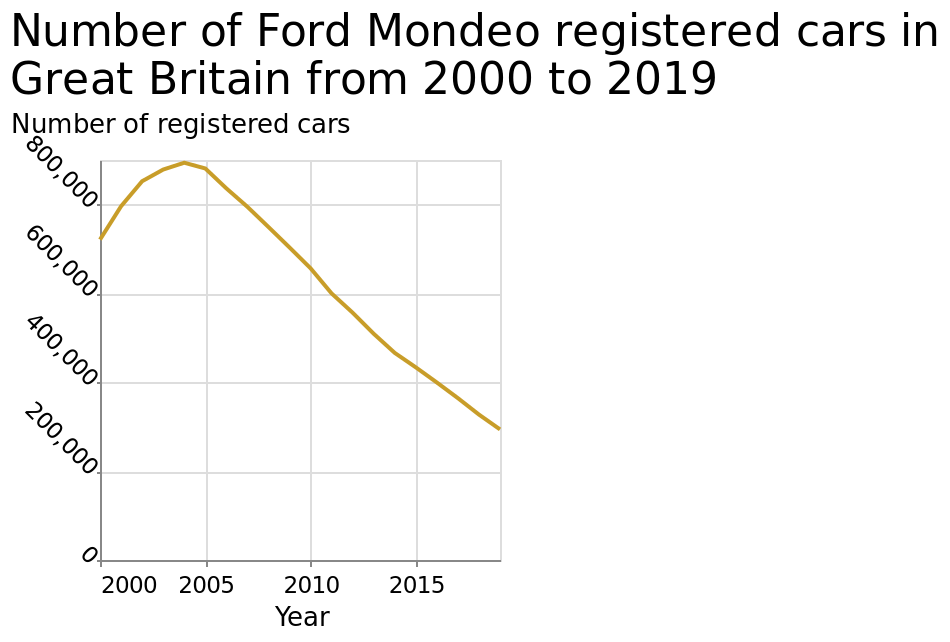<image>
What is the title of the line diagram? The line diagram represents the "Number of Ford Mondeo registered cars in Great Britain from 2000 to 2019". When did the number of registered cars start to decrease?  The number of registered cars started to decrease in 2004. Can you describe the trend in the number of registered cars after 2004? After 2004, the number of registered cars began to decrease. 